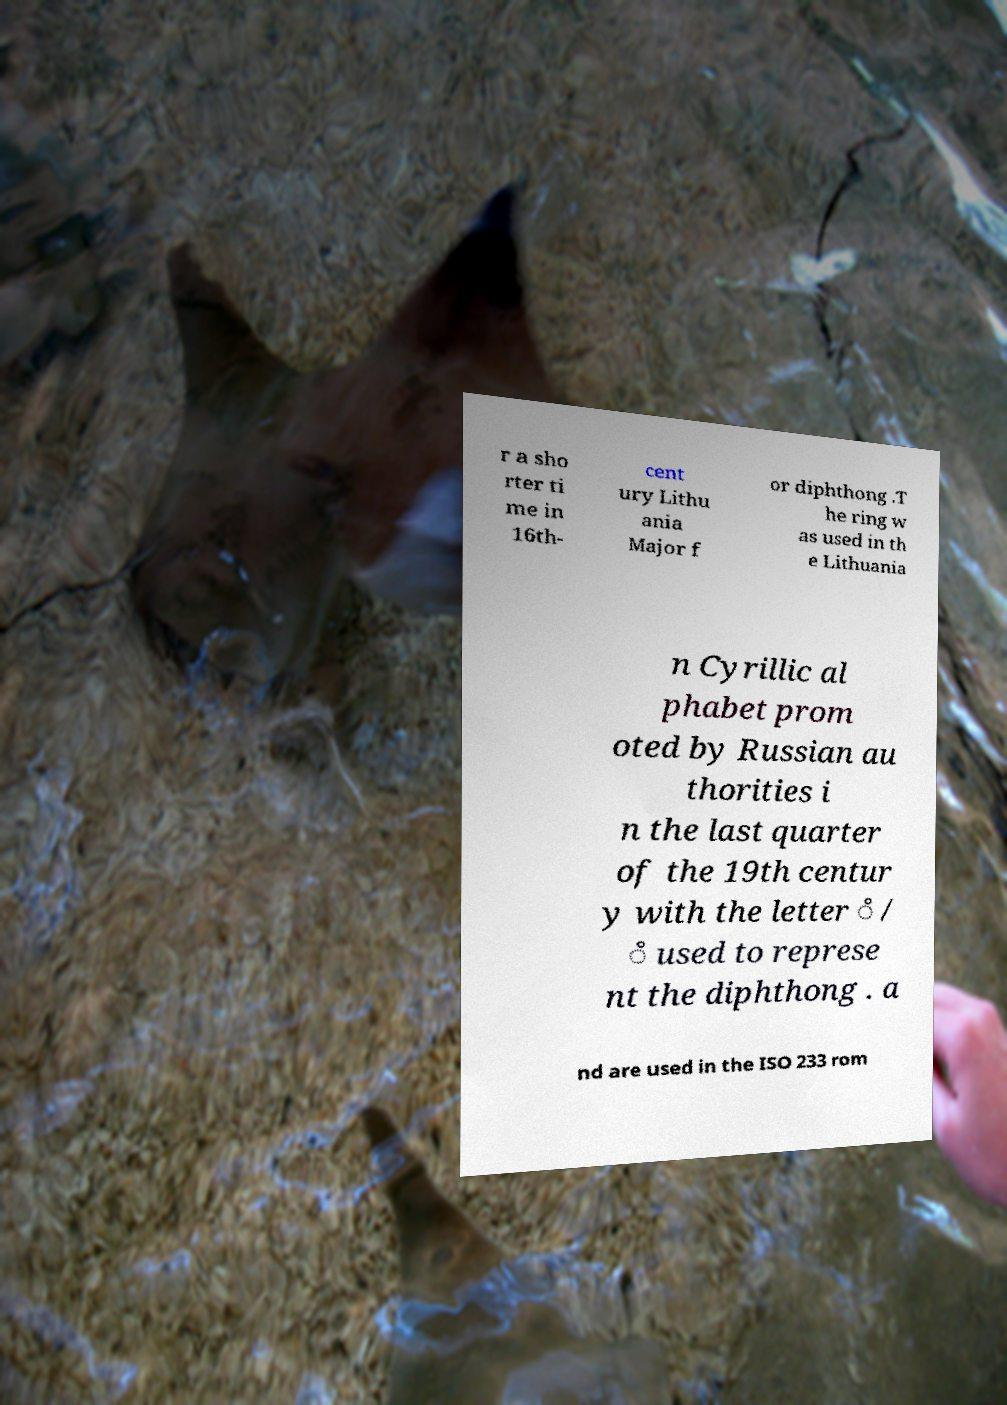Can you read and provide the text displayed in the image?This photo seems to have some interesting text. Can you extract and type it out for me? r a sho rter ti me in 16th- cent ury Lithu ania Major f or diphthong .T he ring w as used in th e Lithuania n Cyrillic al phabet prom oted by Russian au thorities i n the last quarter of the 19th centur y with the letter ̊ / ̊ used to represe nt the diphthong . a nd are used in the ISO 233 rom 